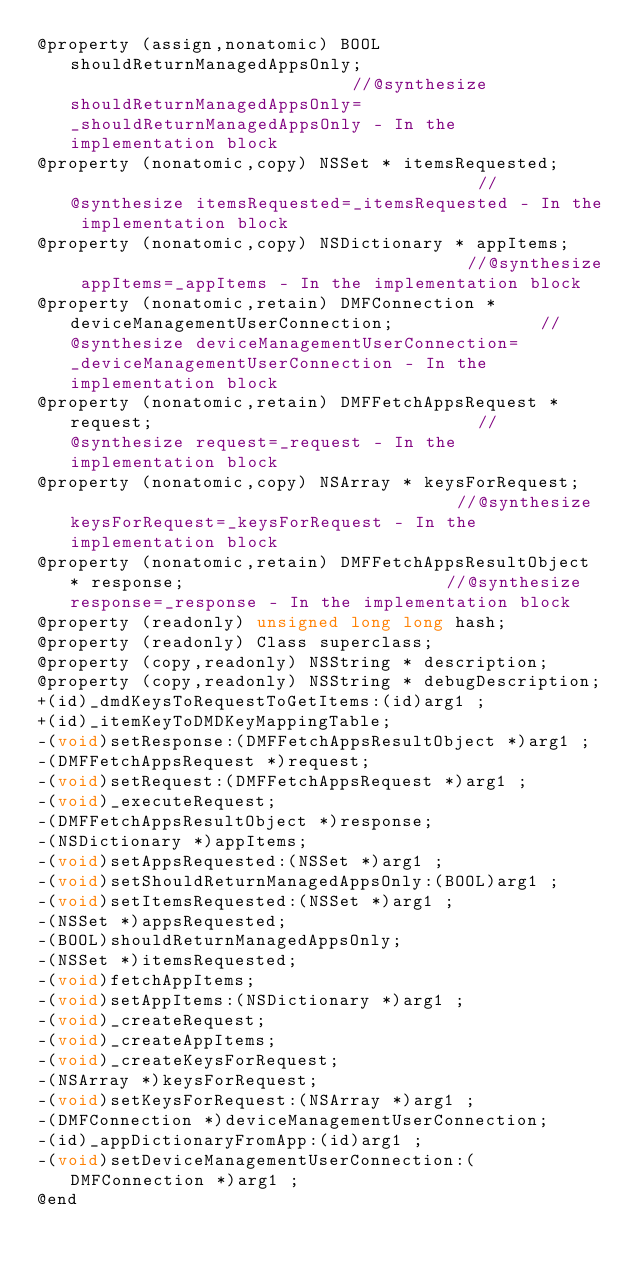<code> <loc_0><loc_0><loc_500><loc_500><_C_>@property (assign,nonatomic) BOOL shouldReturnManagedAppsOnly;                            //@synthesize shouldReturnManagedAppsOnly=_shouldReturnManagedAppsOnly - In the implementation block
@property (nonatomic,copy) NSSet * itemsRequested;                                        //@synthesize itemsRequested=_itemsRequested - In the implementation block
@property (nonatomic,copy) NSDictionary * appItems;                                       //@synthesize appItems=_appItems - In the implementation block
@property (nonatomic,retain) DMFConnection * deviceManagementUserConnection;              //@synthesize deviceManagementUserConnection=_deviceManagementUserConnection - In the implementation block
@property (nonatomic,retain) DMFFetchAppsRequest * request;                               //@synthesize request=_request - In the implementation block
@property (nonatomic,copy) NSArray * keysForRequest;                                      //@synthesize keysForRequest=_keysForRequest - In the implementation block
@property (nonatomic,retain) DMFFetchAppsResultObject * response;                         //@synthesize response=_response - In the implementation block
@property (readonly) unsigned long long hash; 
@property (readonly) Class superclass; 
@property (copy,readonly) NSString * description; 
@property (copy,readonly) NSString * debugDescription; 
+(id)_dmdKeysToRequestToGetItems:(id)arg1 ;
+(id)_itemKeyToDMDKeyMappingTable;
-(void)setResponse:(DMFFetchAppsResultObject *)arg1 ;
-(DMFFetchAppsRequest *)request;
-(void)setRequest:(DMFFetchAppsRequest *)arg1 ;
-(void)_executeRequest;
-(DMFFetchAppsResultObject *)response;
-(NSDictionary *)appItems;
-(void)setAppsRequested:(NSSet *)arg1 ;
-(void)setShouldReturnManagedAppsOnly:(BOOL)arg1 ;
-(void)setItemsRequested:(NSSet *)arg1 ;
-(NSSet *)appsRequested;
-(BOOL)shouldReturnManagedAppsOnly;
-(NSSet *)itemsRequested;
-(void)fetchAppItems;
-(void)setAppItems:(NSDictionary *)arg1 ;
-(void)_createRequest;
-(void)_createAppItems;
-(void)_createKeysForRequest;
-(NSArray *)keysForRequest;
-(void)setKeysForRequest:(NSArray *)arg1 ;
-(DMFConnection *)deviceManagementUserConnection;
-(id)_appDictionaryFromApp:(id)arg1 ;
-(void)setDeviceManagementUserConnection:(DMFConnection *)arg1 ;
@end

</code> 